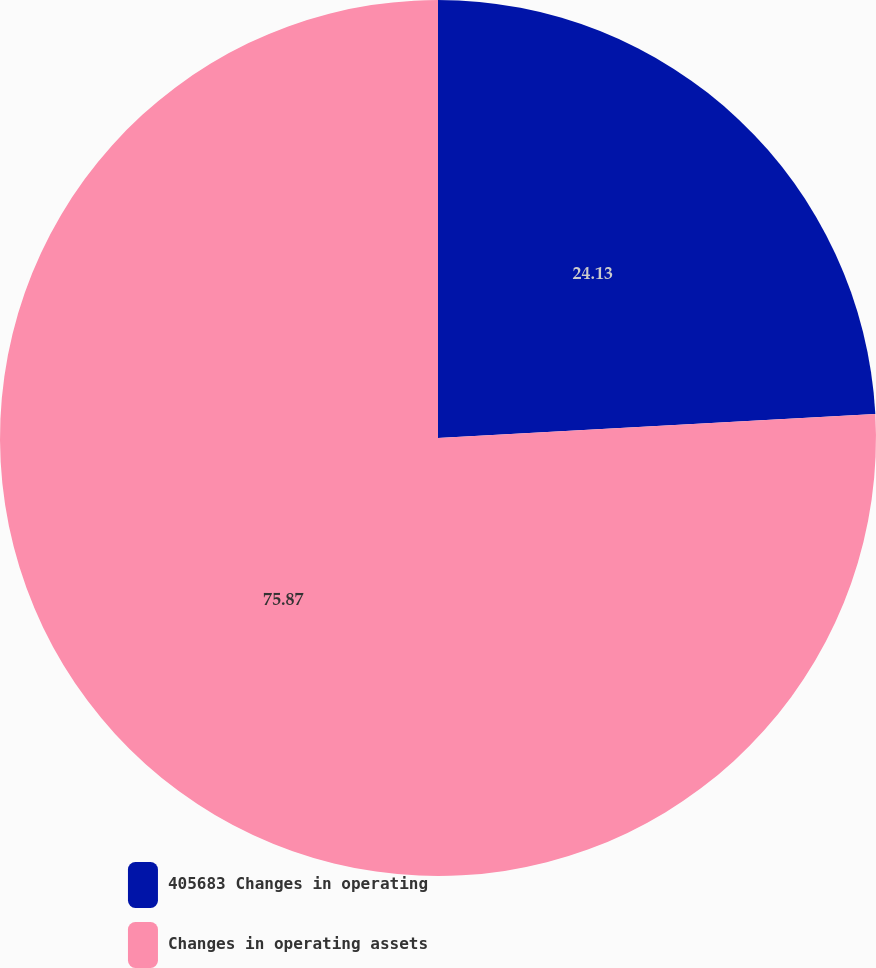Convert chart. <chart><loc_0><loc_0><loc_500><loc_500><pie_chart><fcel>405683 Changes in operating<fcel>Changes in operating assets<nl><fcel>24.13%<fcel>75.87%<nl></chart> 